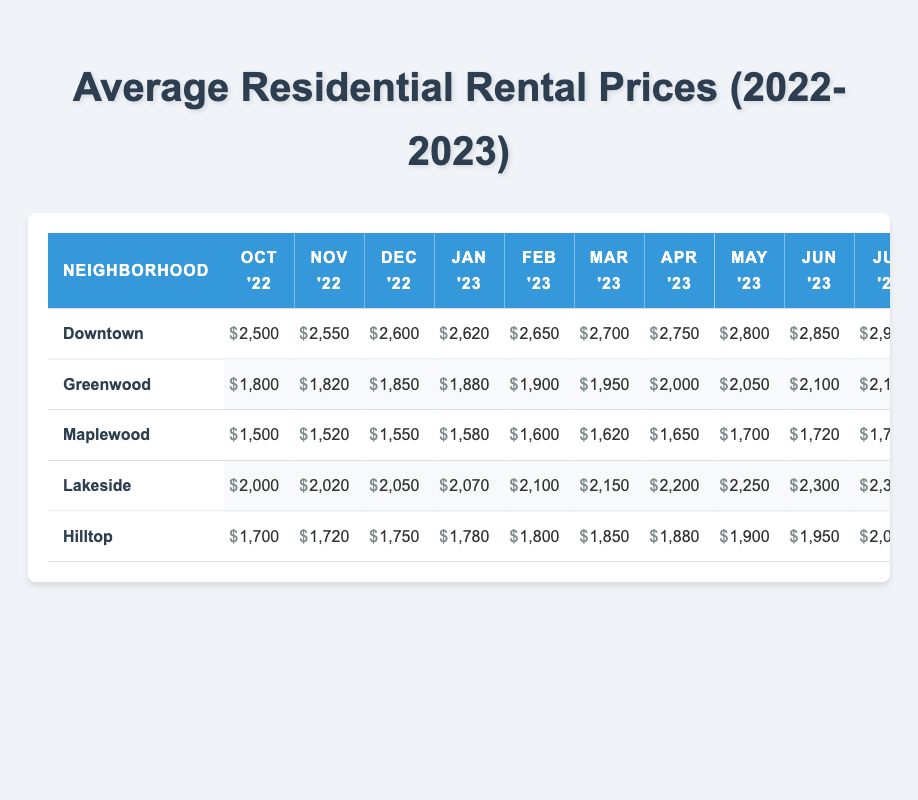What was the average rental price in Downtown in September 2023? The table shows the rental price for Downtown in September 2023 as 3000.
Answer: 3000 Which neighborhood had the lowest average rental price in January 2023? The rental prices in January 2023 were: Downtown (2620), Greenwood (1880), Maplewood (1580), Lakeside (2070), Hilltop (1780). Maplewood had the lowest price at 1580.
Answer: Maplewood What is the increase in rental price for Lakeside from October 2022 to September 2023? The rent in Lakeside was 2000 in October 2022 and 2450 in September 2023. The increase is 2450 - 2000 = 450.
Answer: 450 Was the average rental price in Hilltop higher than in Greenwood during March 2023? Hilltop had a rental price of 1850 and Greenwood had 1950 in March 2023. Since 1850 < 1950, it is false that Hilltop was higher.
Answer: No What is the average rental price across all neighborhoods in May 2023? The prices in May 2023 were: Downtown (2800), Greenwood (2050), Maplewood (1700), Lakeside (2250), Hilltop (1900). The total is 2800 + 2050 + 1700 + 2250 + 1900 = 12600, and the average is 12600 / 5 = 2520.
Answer: 2520 Which neighborhood saw the largest percentage increase in rental price from October 2022 to September 2023? The rental prices in October 2022 and September 2023 were: Downtown (2500 to 3000), Greenwood (1800 to 2250), Maplewood (1500 to 1825), Lakeside (2000 to 2450), Hilltop (1700 to 2050). The largest increase is in Downtown: (3000 - 2500) / 2500 * 100 = 20%.
Answer: Downtown What was the trend in rental prices for Maplewood over the past year? By observing the data from October 2022 (1500) to September 2023 (1825), it shows a consistent upward trend, as the prices increase each month. The change is always positive.
Answer: Upward trend Did any neighborhood experience a decrease in rental price between any two consecutive months? Checking the data for all neighborhoods, there is no instance where a monthly rental price decreased from one month to the next.
Answer: No What was the average rental price for those neighborhoods in February 2023? The rental prices in February 2023 were: Downtown (2650), Greenwood (1900), Maplewood (1600), Lakeside (2100), Hilltop (1800). The total is 2650 + 1900 + 1600 + 2100 + 1800 = 11150, so the average is 11150 / 5 = 2230.
Answer: 2230 Which neighborhood had the highest rental price in June 2023? The rental prices in June 2023 were: Downtown (2850), Greenwood (2100), Maplewood (1720), Lakeside (2300), Hilltop (1950). Downtown had the highest price at 2850.
Answer: Downtown 